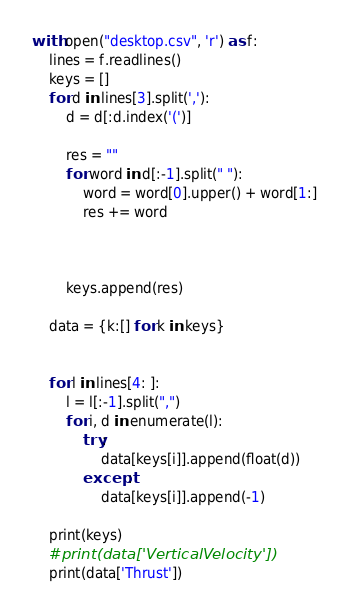<code> <loc_0><loc_0><loc_500><loc_500><_Python_>with open("desktop.csv", 'r') as f:
    lines = f.readlines()
    keys = []
    for d in lines[3].split(','):
        d = d[:d.index('(')]
        
        res = ""
        for word in d[:-1].split(" "):
            word = word[0].upper() + word[1:]
            res += word
        


        keys.append(res)

    data = {k:[] for k in keys}


    for l in lines[4: ]:
        l = l[:-1].split(",")
        for i, d in enumerate(l):
            try:
                data[keys[i]].append(float(d)) 
            except:
                data[keys[i]].append(-1) 

    print(keys)
    #print(data['VerticalVelocity'])
    print(data['Thrust'])
</code> 